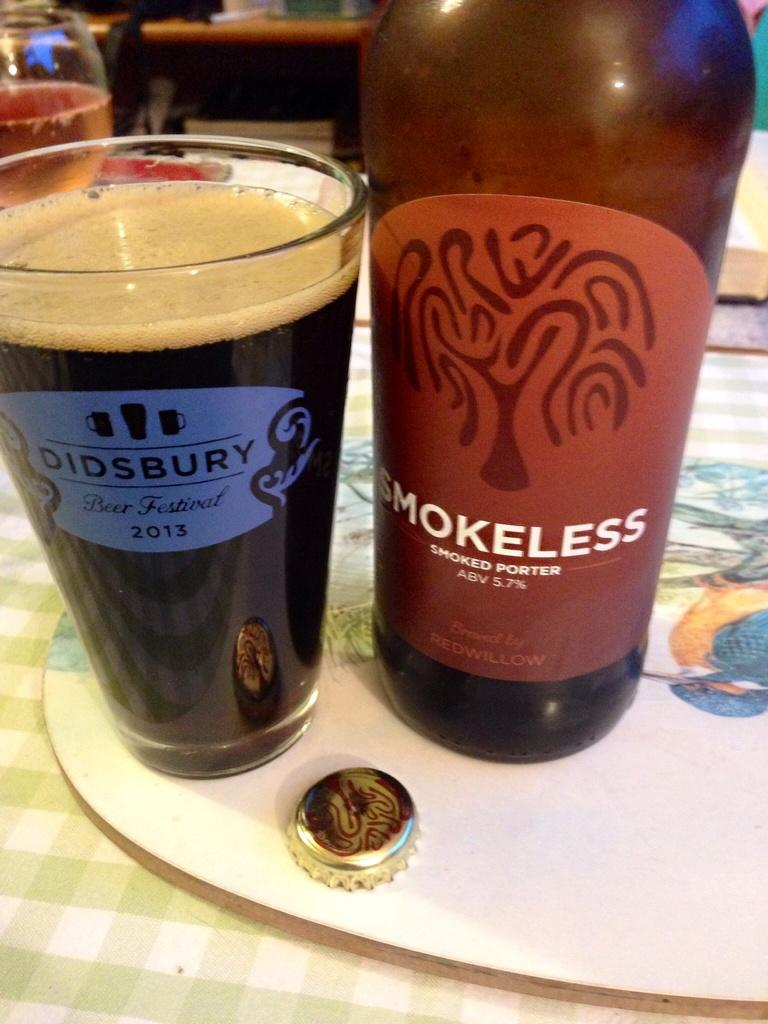Provide a one-sentence caption for the provided image. A smoked porter wine bottle is next to a glass with the year 2013 on it. 